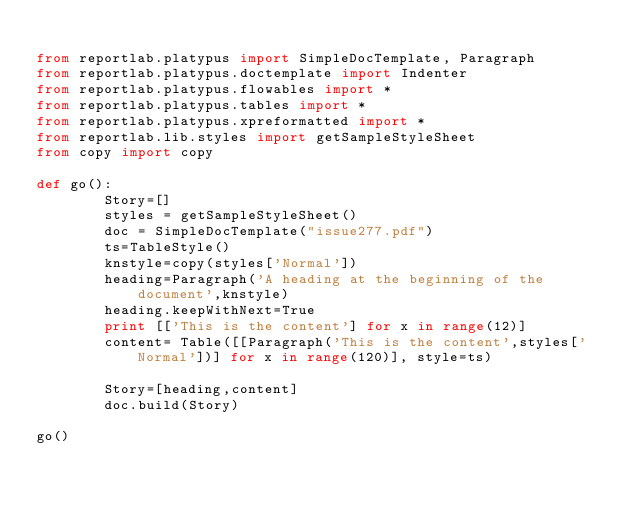Convert code to text. <code><loc_0><loc_0><loc_500><loc_500><_Python_>
from reportlab.platypus import SimpleDocTemplate, Paragraph
from reportlab.platypus.doctemplate import Indenter
from reportlab.platypus.flowables import *
from reportlab.platypus.tables import *
from reportlab.platypus.xpreformatted import *
from reportlab.lib.styles import getSampleStyleSheet
from copy import copy

def go():
        Story=[]
        styles = getSampleStyleSheet()
        doc = SimpleDocTemplate("issue277.pdf")
        ts=TableStyle()
        knstyle=copy(styles['Normal'])
        heading=Paragraph('A heading at the beginning of the document',knstyle)
        heading.keepWithNext=True
        print [['This is the content'] for x in range(12)]
        content= Table([[Paragraph('This is the content',styles['Normal'])] for x in range(120)], style=ts)

        Story=[heading,content]
        doc.build(Story)

go()
</code> 